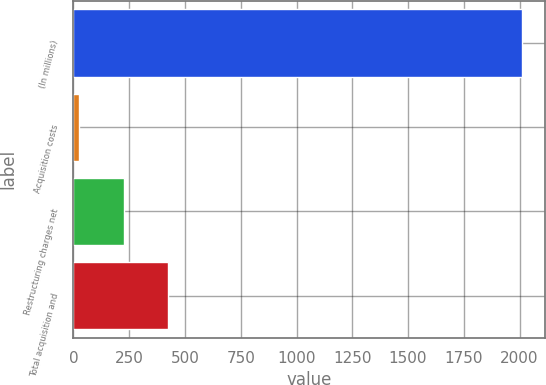<chart> <loc_0><loc_0><loc_500><loc_500><bar_chart><fcel>(In millions)<fcel>Acquisition costs<fcel>Restructuring charges net<fcel>Total acquisition and<nl><fcel>2012<fcel>26<fcel>224.6<fcel>423.2<nl></chart> 